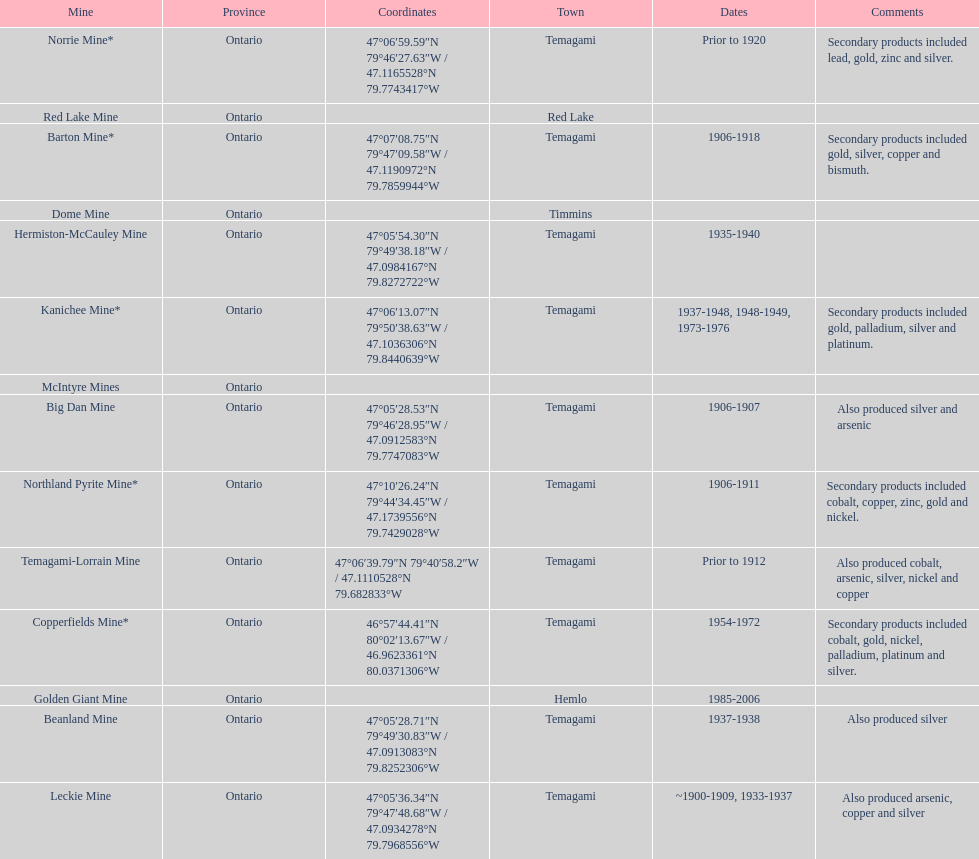Name a gold mine that was open at least 10 years. Barton Mine. 